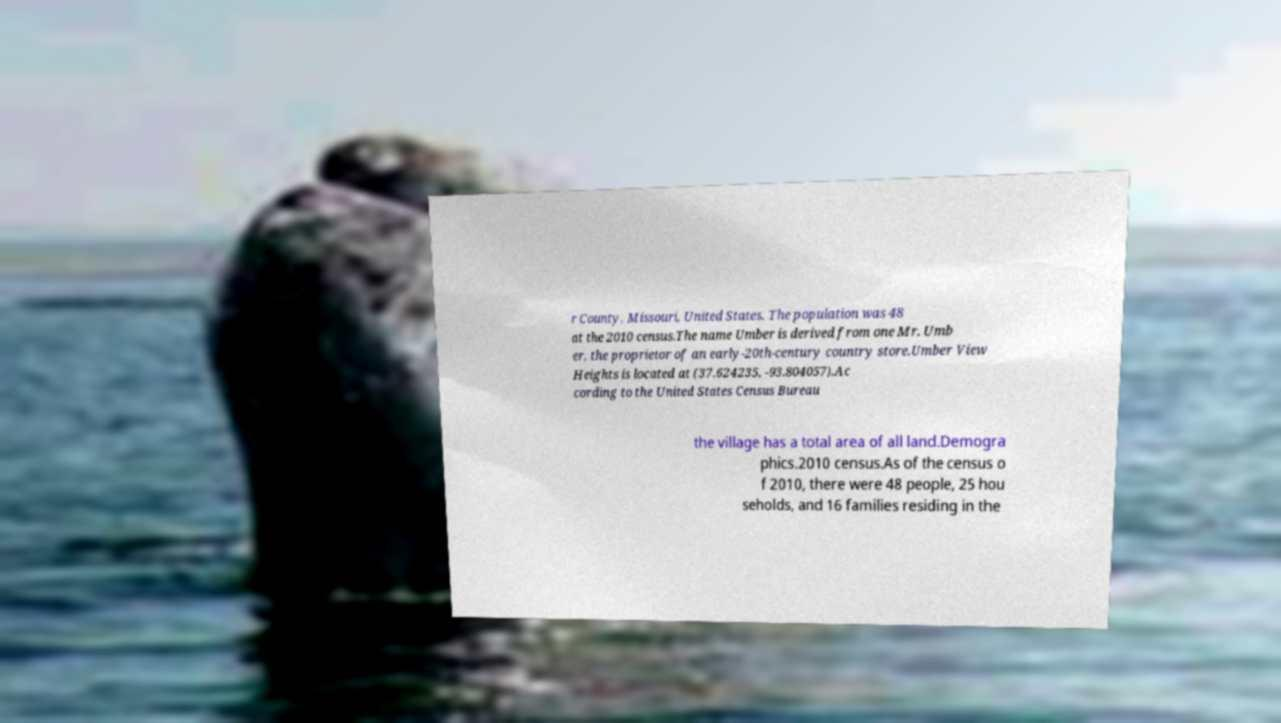Could you assist in decoding the text presented in this image and type it out clearly? r County, Missouri, United States. The population was 48 at the 2010 census.The name Umber is derived from one Mr. Umb er, the proprietor of an early-20th-century country store.Umber View Heights is located at (37.624235, -93.804057).Ac cording to the United States Census Bureau the village has a total area of all land.Demogra phics.2010 census.As of the census o f 2010, there were 48 people, 25 hou seholds, and 16 families residing in the 